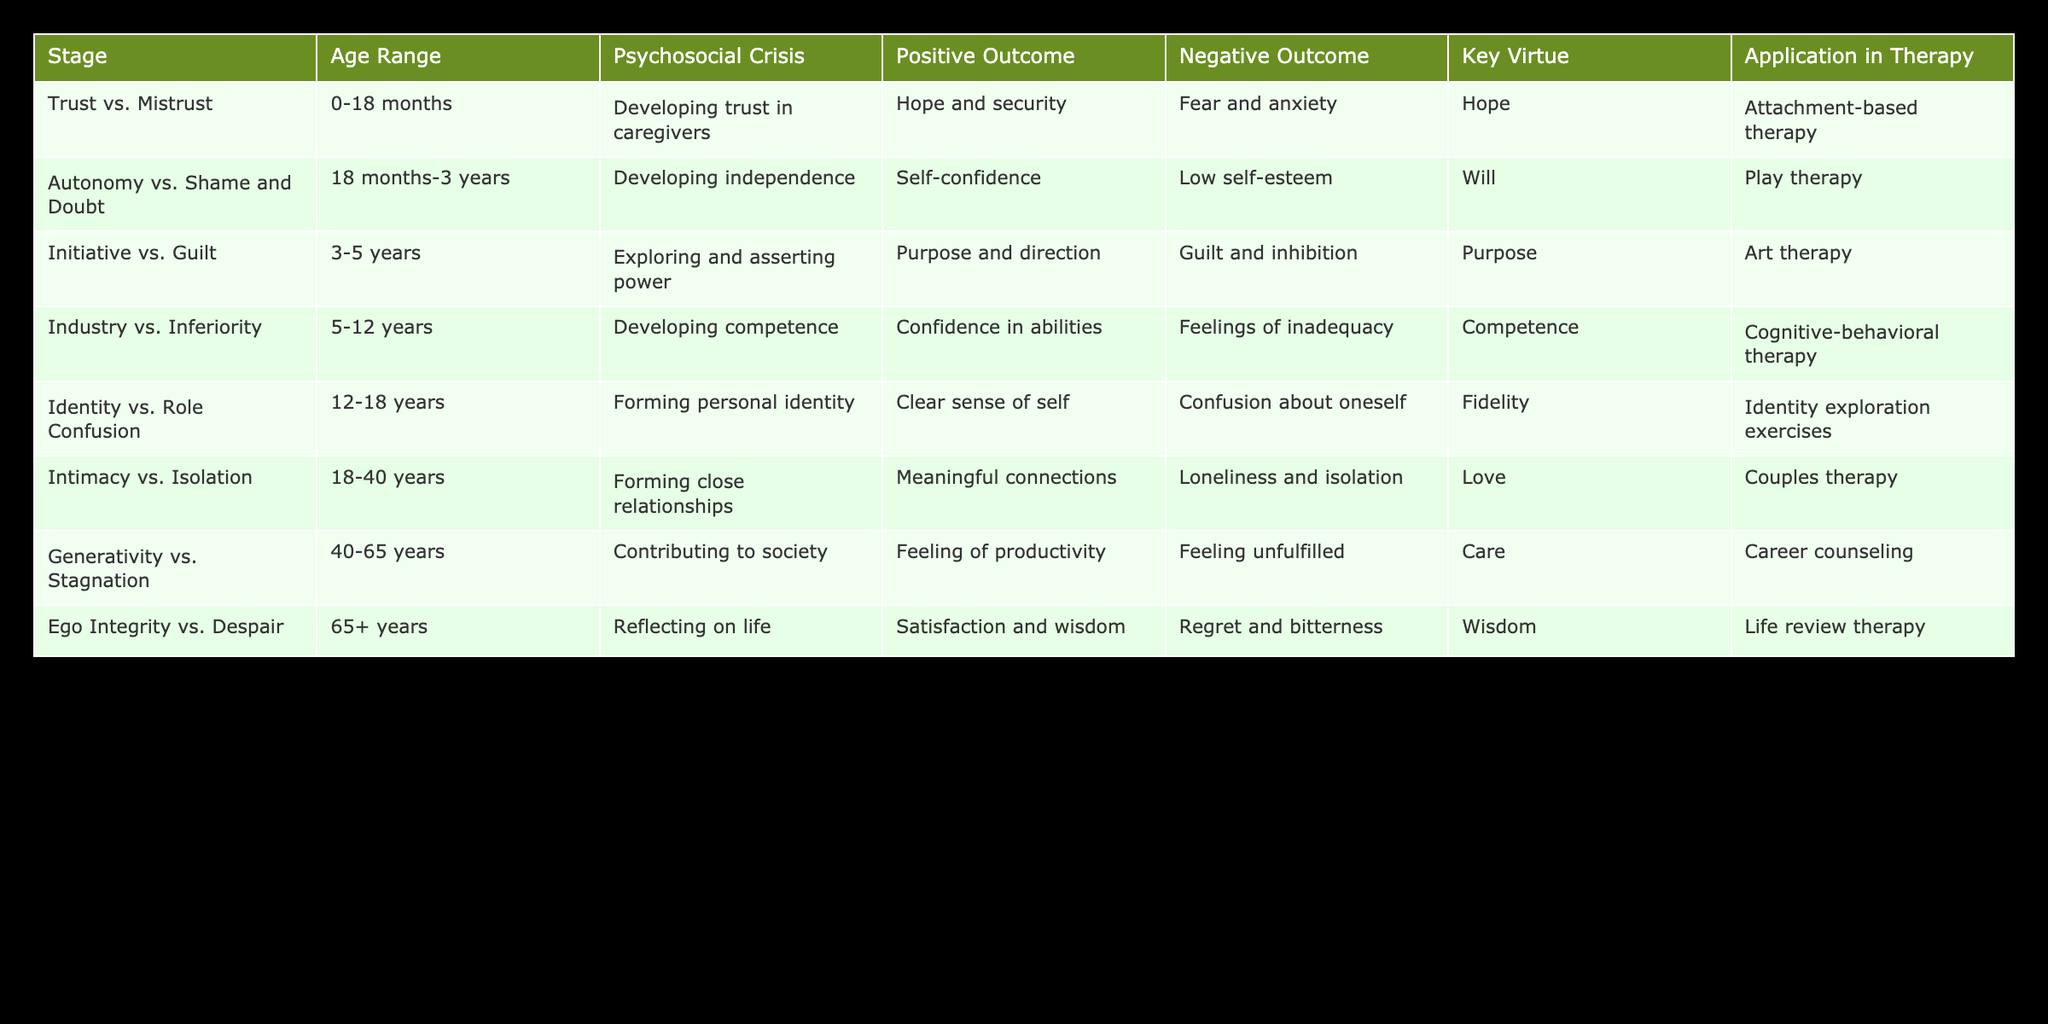What is the psychosocial crisis associated with the stage of "Initiative vs. Guilt"? The table shows that the psychosocial crisis for "Initiative vs. Guilt" is "Exploring and asserting power". This information can be directly retrieved from the "Psychosocial Crisis" column in the corresponding row.
Answer: Exploring and asserting power Which age range corresponds to the stage of "Generativity vs. Stagnation"? According to the table, the age range for "Generativity vs. Stagnation" is "40-65 years". This can be confirmed by locating the specific row for that stage.
Answer: 40-65 years Is the key virtue for "Intimacy vs. Isolation" noted in the table? Yes, the key virtue for "Intimacy vs. Isolation" is listed as "Love". Looking at the corresponding row, this information is clearly indicated.
Answer: Yes What is the positive outcome of the "Ego Integrity vs. Despair" stage? The positive outcome for the "Ego Integrity vs. Despair" stage is stated as "Satisfaction and wisdom" in the table. This is found under the "Positive Outcome" column in the relevant row.
Answer: Satisfaction and wisdom How many stages involve the development of trust, autonomy, or identity? To determine this, we need to look for instances of "Trust" (Trust vs. Mistrust), "Autonomy" (Autonomy vs. Shame and Doubt), and "Identity" (Identity vs. Role Confusion) in the stages. There are three such stages: "Trust vs. Mistrust", "Autonomy vs. Shame and Doubt", and "Identity vs. Role Confusion". Therefore, the sum is 3.
Answer: 3 What is the relationship between positive outcomes and key virtues in terms of the earliest and latest stages? The earliest stage, "Trust vs. Mistrust", has the positive outcome of "Hope and security" with the key virtue being "Hope". The latest stage, "Ego Integrity vs. Despair", has "Satisfaction and wisdom" as the positive outcome and "Wisdom" as the key virtue. This comparison shows that both outcomes promote a sense of fulfillment, indicating continuity in psychological growth.
Answer: The outcomes promote a sense of fulfillment Which stage has the negative outcome of "Loneliness and isolation"? The stage with the negative outcome of "Loneliness and isolation" is "Intimacy vs. Isolation". This can be seen under the "Negative Outcome" column in the corresponding row for that stage.
Answer: Intimacy vs. Isolation Can we conclude that "Industry vs. Inferiority" presents a key virtue of “Competence”? Yes, the key virtue for "Industry vs. Inferiority" as seen in the table is indeed "Competence". This conclusion can be drawn by looking directly under the "Key Virtue" column for that specific stage.
Answer: Yes 